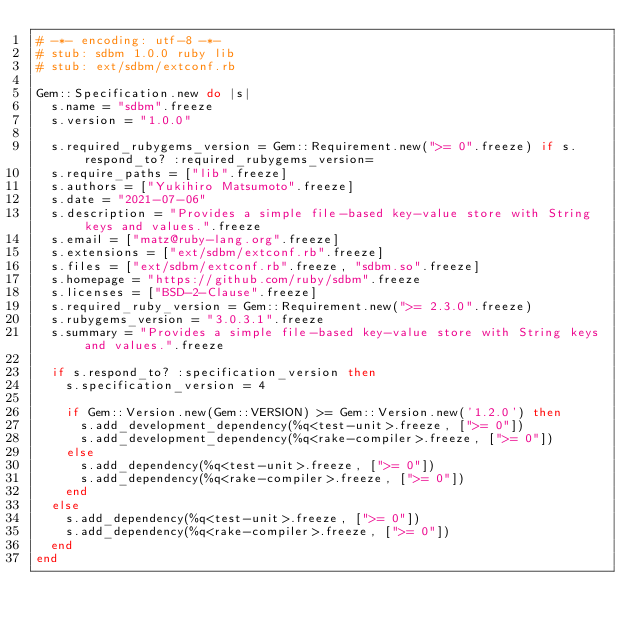Convert code to text. <code><loc_0><loc_0><loc_500><loc_500><_Ruby_># -*- encoding: utf-8 -*-
# stub: sdbm 1.0.0 ruby lib
# stub: ext/sdbm/extconf.rb

Gem::Specification.new do |s|
  s.name = "sdbm".freeze
  s.version = "1.0.0"

  s.required_rubygems_version = Gem::Requirement.new(">= 0".freeze) if s.respond_to? :required_rubygems_version=
  s.require_paths = ["lib".freeze]
  s.authors = ["Yukihiro Matsumoto".freeze]
  s.date = "2021-07-06"
  s.description = "Provides a simple file-based key-value store with String keys and values.".freeze
  s.email = ["matz@ruby-lang.org".freeze]
  s.extensions = ["ext/sdbm/extconf.rb".freeze]
  s.files = ["ext/sdbm/extconf.rb".freeze, "sdbm.so".freeze]
  s.homepage = "https://github.com/ruby/sdbm".freeze
  s.licenses = ["BSD-2-Clause".freeze]
  s.required_ruby_version = Gem::Requirement.new(">= 2.3.0".freeze)
  s.rubygems_version = "3.0.3.1".freeze
  s.summary = "Provides a simple file-based key-value store with String keys and values.".freeze

  if s.respond_to? :specification_version then
    s.specification_version = 4

    if Gem::Version.new(Gem::VERSION) >= Gem::Version.new('1.2.0') then
      s.add_development_dependency(%q<test-unit>.freeze, [">= 0"])
      s.add_development_dependency(%q<rake-compiler>.freeze, [">= 0"])
    else
      s.add_dependency(%q<test-unit>.freeze, [">= 0"])
      s.add_dependency(%q<rake-compiler>.freeze, [">= 0"])
    end
  else
    s.add_dependency(%q<test-unit>.freeze, [">= 0"])
    s.add_dependency(%q<rake-compiler>.freeze, [">= 0"])
  end
end
</code> 